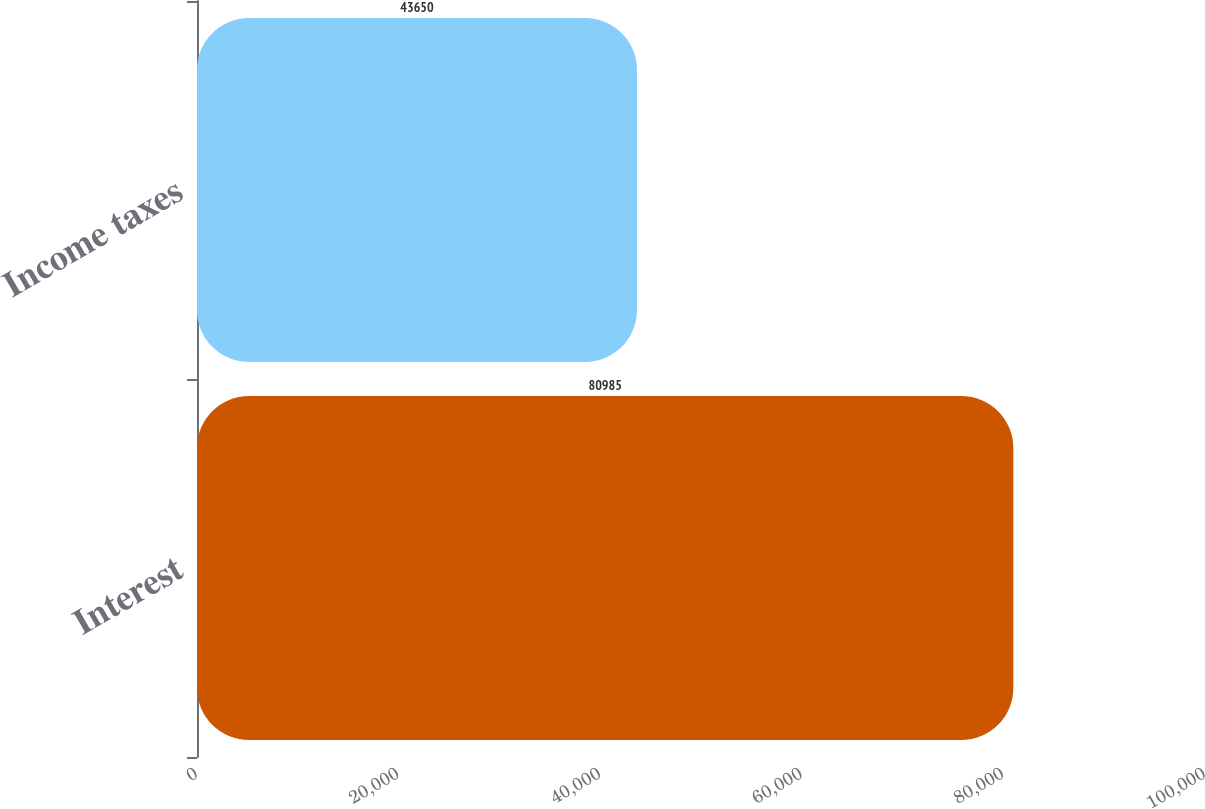Convert chart. <chart><loc_0><loc_0><loc_500><loc_500><bar_chart><fcel>Interest<fcel>Income taxes<nl><fcel>80985<fcel>43650<nl></chart> 